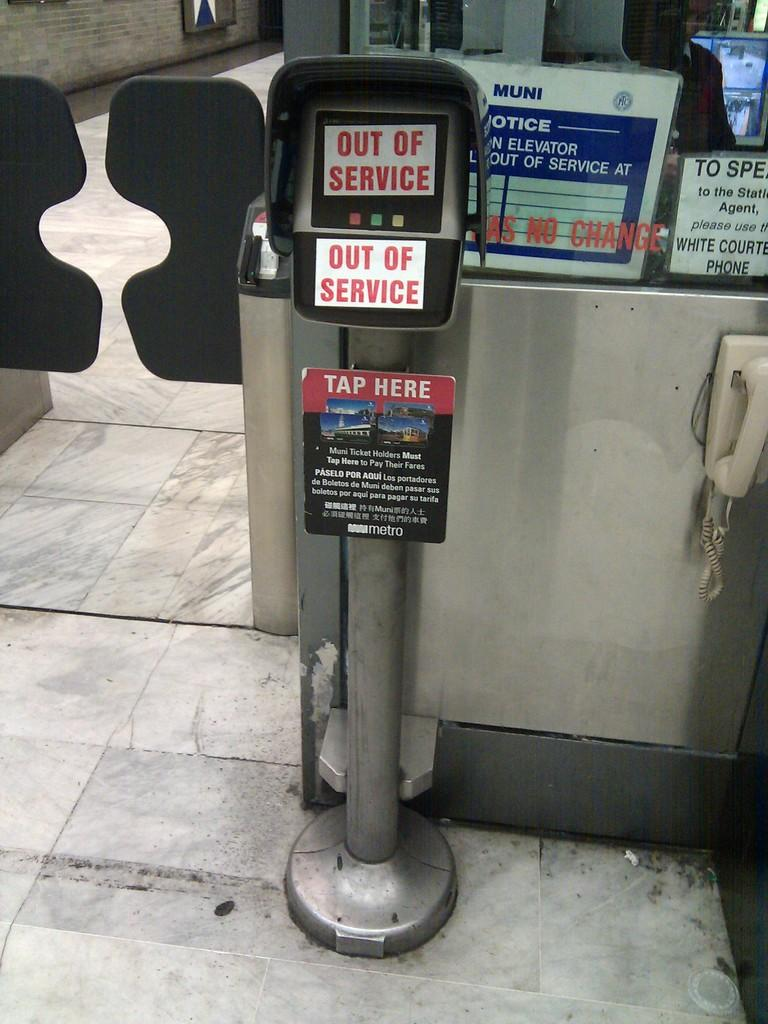What is the main object in the image? There is a machine in the image. What else can be seen on the right side of the image? There is a board with text on the right side of the image. What type of lock is used to secure the machine in the image? There is no lock visible in the image, as it only features a machine and a board with text. 